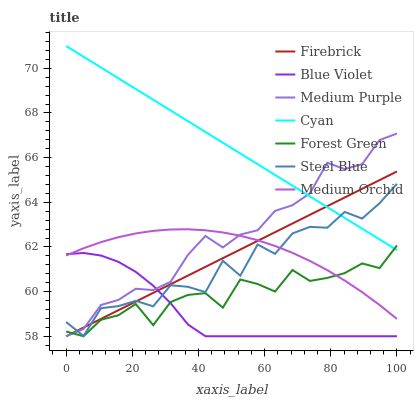Does Blue Violet have the minimum area under the curve?
Answer yes or no. Yes. Does Cyan have the maximum area under the curve?
Answer yes or no. Yes. Does Medium Orchid have the minimum area under the curve?
Answer yes or no. No. Does Medium Orchid have the maximum area under the curve?
Answer yes or no. No. Is Cyan the smoothest?
Answer yes or no. Yes. Is Steel Blue the roughest?
Answer yes or no. Yes. Is Medium Orchid the smoothest?
Answer yes or no. No. Is Medium Orchid the roughest?
Answer yes or no. No. Does Firebrick have the lowest value?
Answer yes or no. Yes. Does Medium Orchid have the lowest value?
Answer yes or no. No. Does Cyan have the highest value?
Answer yes or no. Yes. Does Medium Orchid have the highest value?
Answer yes or no. No. Is Blue Violet less than Cyan?
Answer yes or no. Yes. Is Cyan greater than Blue Violet?
Answer yes or no. Yes. Does Forest Green intersect Blue Violet?
Answer yes or no. Yes. Is Forest Green less than Blue Violet?
Answer yes or no. No. Is Forest Green greater than Blue Violet?
Answer yes or no. No. Does Blue Violet intersect Cyan?
Answer yes or no. No. 